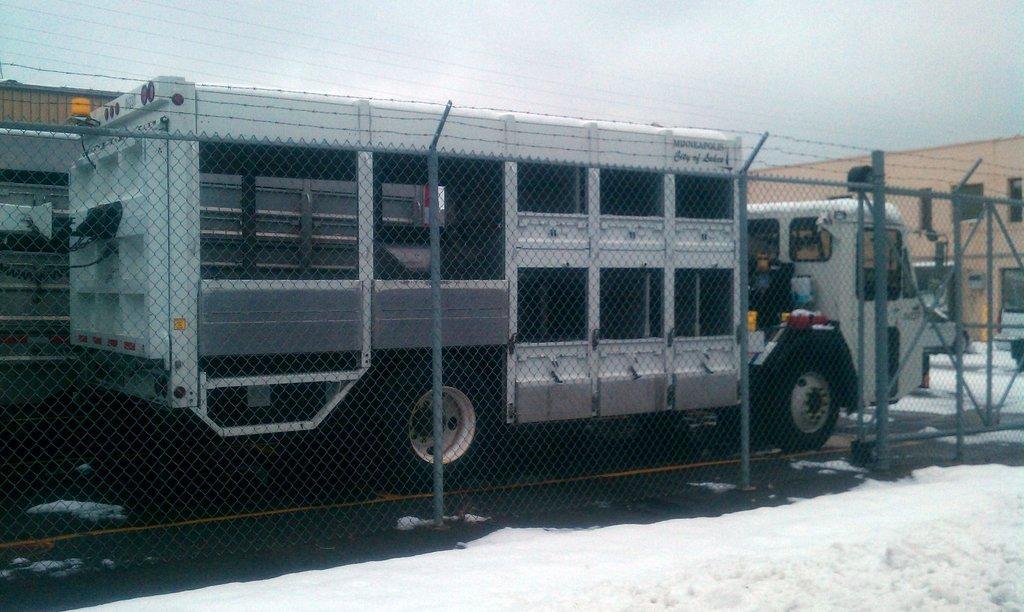Could you give a brief overview of what you see in this image? In this picture we can see a fence, here we can see vehicles on the ground and we can see a building and we can see sky in the background. 